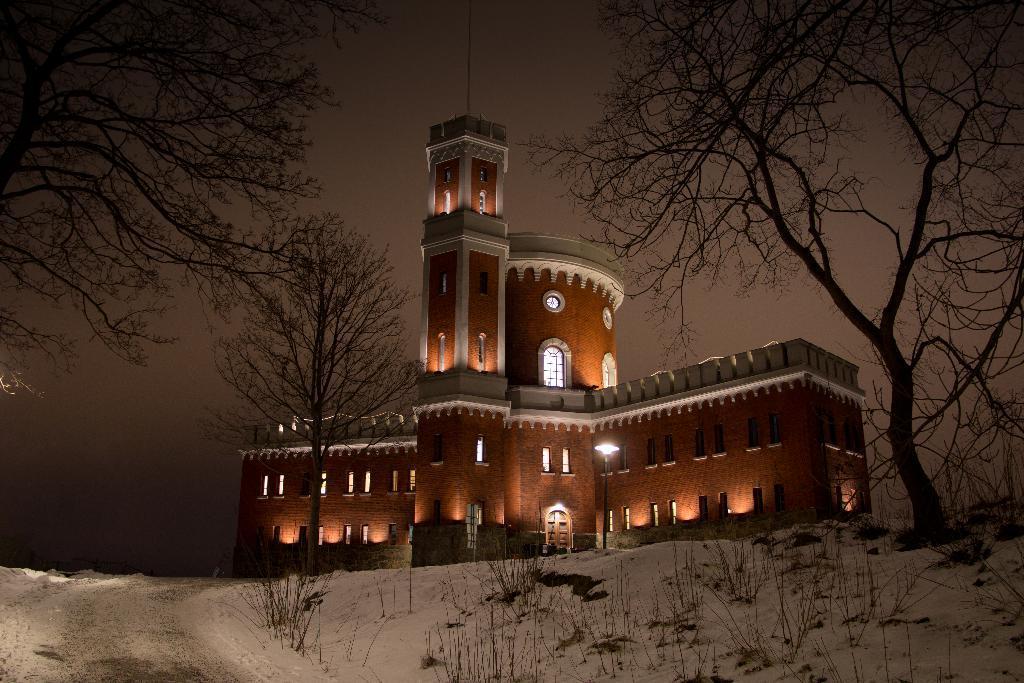How would you summarize this image in a sentence or two? In the picture we can see a building with, which is brown in color with white color borders to it with many windows and lights and near the building we can see a snow slope with dried trees and in the background we can see the sky. 